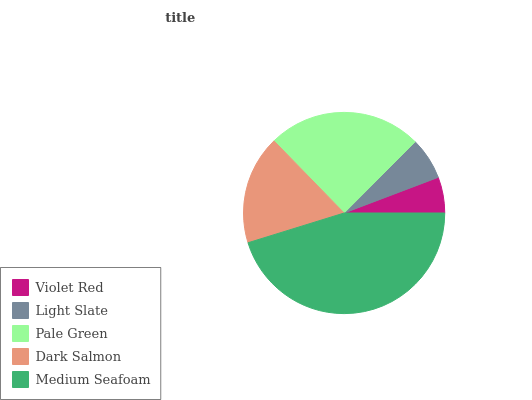Is Violet Red the minimum?
Answer yes or no. Yes. Is Medium Seafoam the maximum?
Answer yes or no. Yes. Is Light Slate the minimum?
Answer yes or no. No. Is Light Slate the maximum?
Answer yes or no. No. Is Light Slate greater than Violet Red?
Answer yes or no. Yes. Is Violet Red less than Light Slate?
Answer yes or no. Yes. Is Violet Red greater than Light Slate?
Answer yes or no. No. Is Light Slate less than Violet Red?
Answer yes or no. No. Is Dark Salmon the high median?
Answer yes or no. Yes. Is Dark Salmon the low median?
Answer yes or no. Yes. Is Pale Green the high median?
Answer yes or no. No. Is Light Slate the low median?
Answer yes or no. No. 